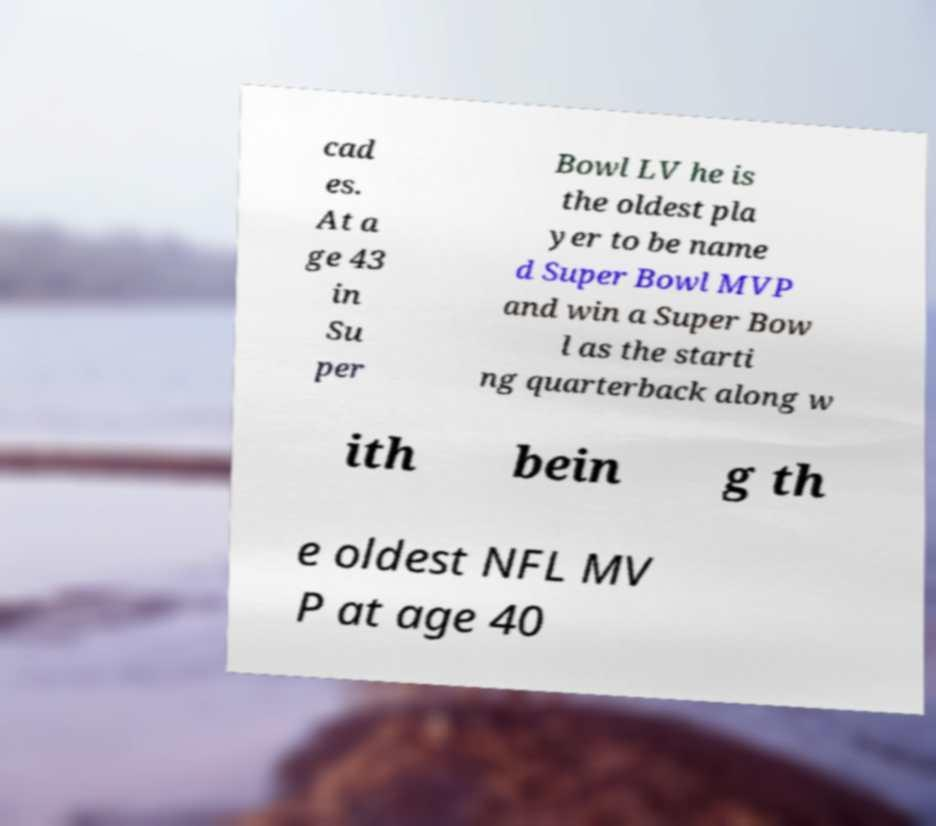Can you accurately transcribe the text from the provided image for me? cad es. At a ge 43 in Su per Bowl LV he is the oldest pla yer to be name d Super Bowl MVP and win a Super Bow l as the starti ng quarterback along w ith bein g th e oldest NFL MV P at age 40 